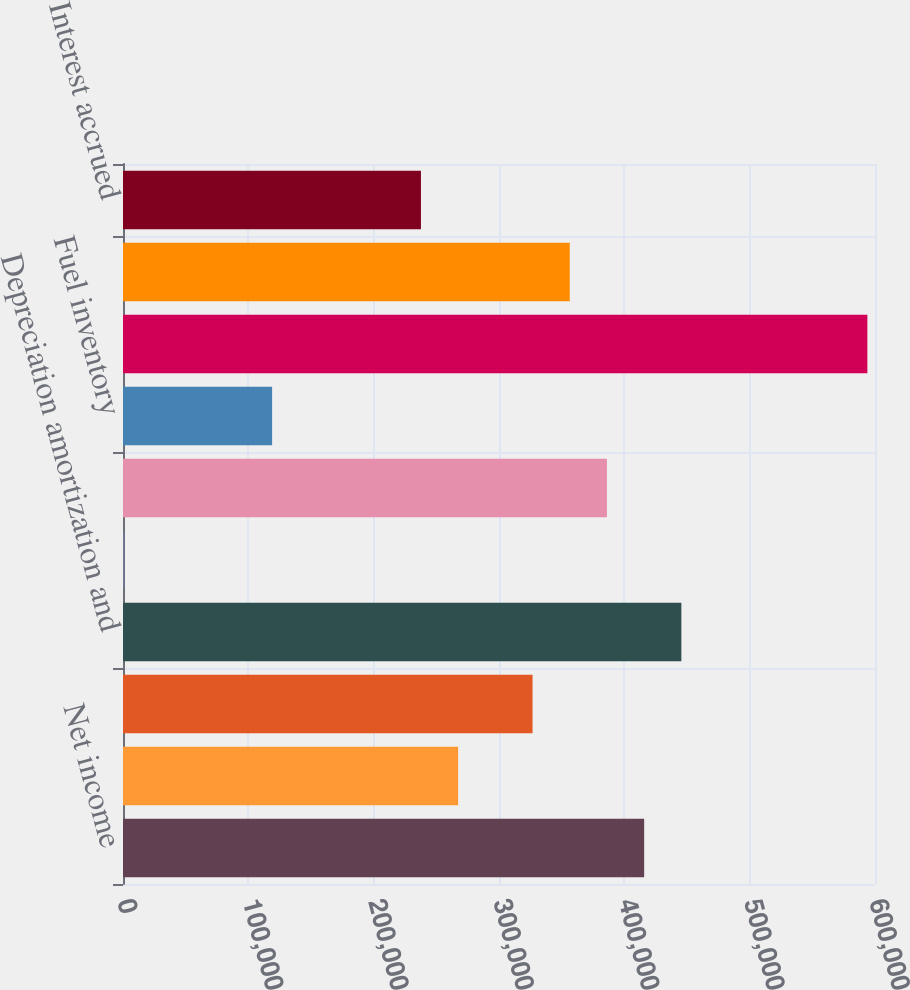Convert chart. <chart><loc_0><loc_0><loc_500><loc_500><bar_chart><fcel>Net income<fcel>Reserve for regulatory<fcel>Other regulatory charges - net<fcel>Depreciation amortization and<fcel>Deferred income taxes<fcel>Receivables<fcel>Fuel inventory<fcel>Accounts payable<fcel>Taxes accrued<fcel>Interest accrued<nl><fcel>415813<fcel>267399<fcel>326765<fcel>445496<fcel>255<fcel>386130<fcel>118986<fcel>593909<fcel>356447<fcel>237717<nl></chart> 